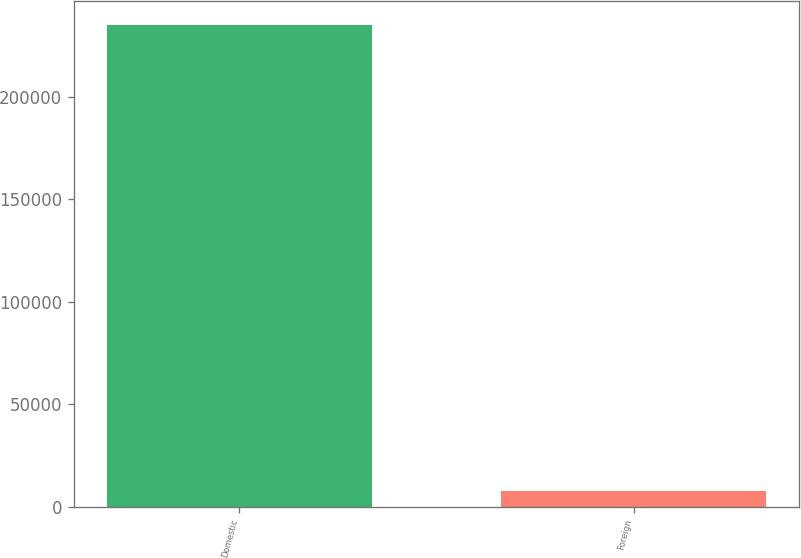<chart> <loc_0><loc_0><loc_500><loc_500><bar_chart><fcel>Domestic<fcel>Foreign<nl><fcel>235204<fcel>7818<nl></chart> 